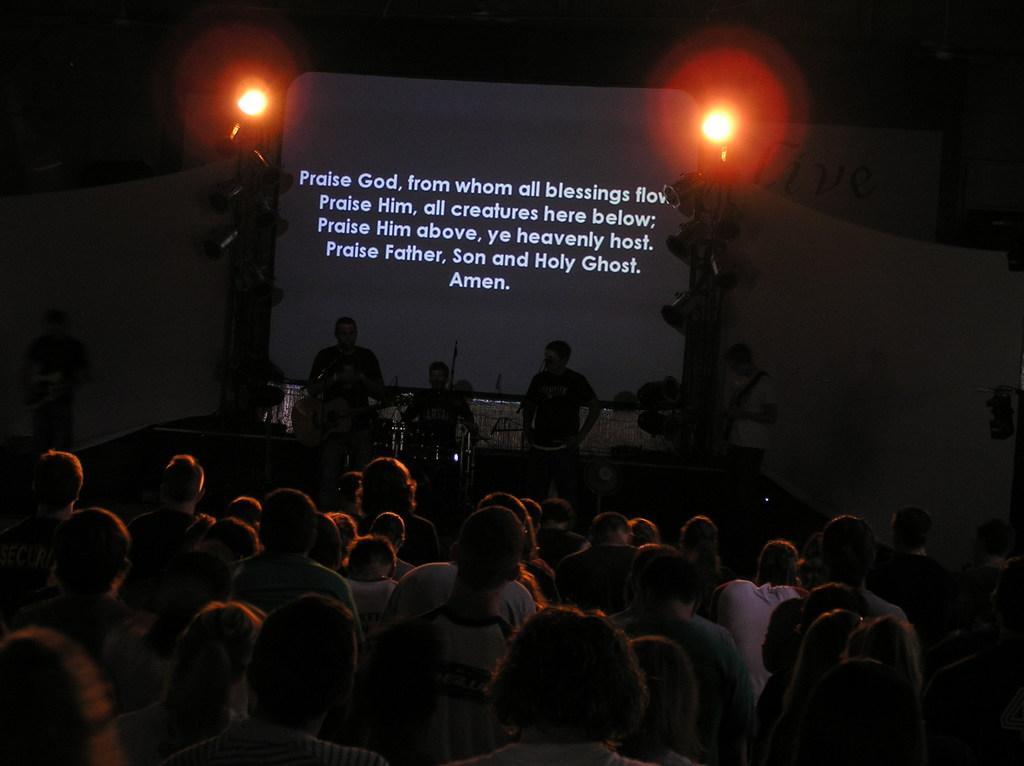Please provide a concise description of this image. In this image, at the bottom there are many people. In the middle there are people, some are playing musical instruments. At the top there is a screen on that there is a text and there are lights, poles, banners. 